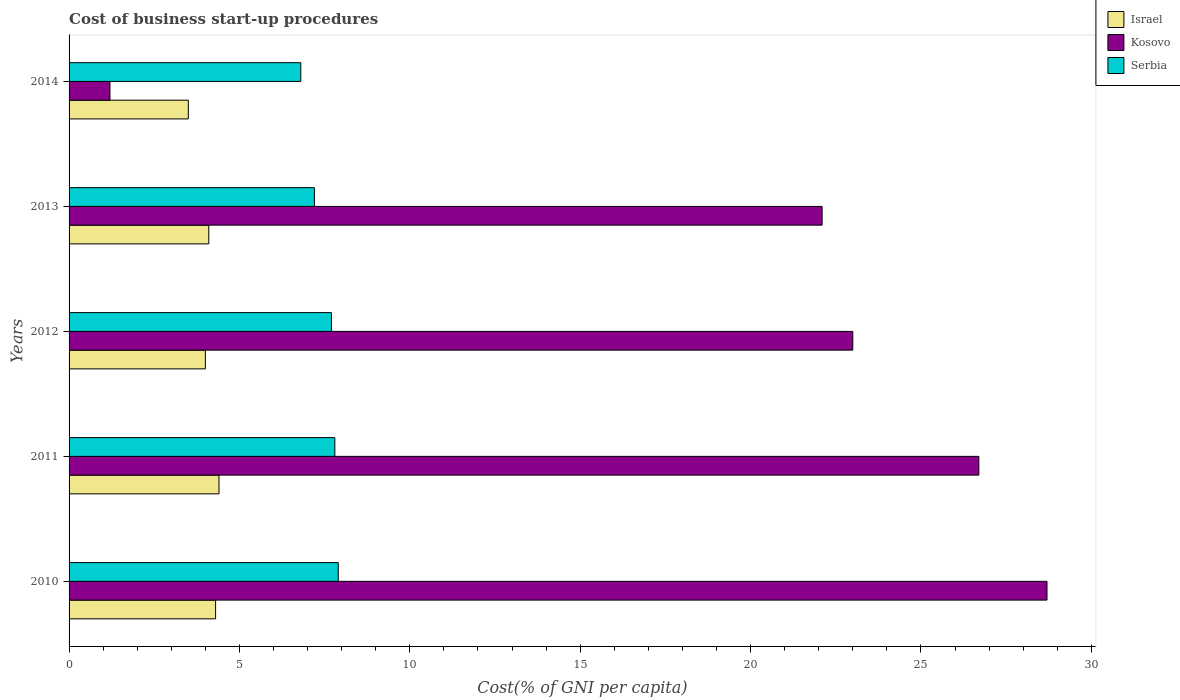How many different coloured bars are there?
Provide a short and direct response. 3. Are the number of bars per tick equal to the number of legend labels?
Give a very brief answer. Yes. In how many cases, is the number of bars for a given year not equal to the number of legend labels?
Offer a very short reply. 0. Across all years, what is the minimum cost of business start-up procedures in Israel?
Your answer should be very brief. 3.5. In which year was the cost of business start-up procedures in Serbia maximum?
Offer a terse response. 2010. What is the total cost of business start-up procedures in Israel in the graph?
Your answer should be very brief. 20.3. What is the difference between the cost of business start-up procedures in Kosovo in 2012 and that in 2014?
Provide a short and direct response. 21.8. What is the difference between the cost of business start-up procedures in Kosovo in 2011 and the cost of business start-up procedures in Israel in 2012?
Your answer should be very brief. 22.7. What is the average cost of business start-up procedures in Israel per year?
Make the answer very short. 4.06. What is the ratio of the cost of business start-up procedures in Kosovo in 2012 to that in 2014?
Give a very brief answer. 19.17. What is the difference between the highest and the second highest cost of business start-up procedures in Israel?
Make the answer very short. 0.1. What is the difference between the highest and the lowest cost of business start-up procedures in Israel?
Your answer should be very brief. 0.9. What does the 2nd bar from the top in 2014 represents?
Ensure brevity in your answer.  Kosovo. How many years are there in the graph?
Ensure brevity in your answer.  5. What is the difference between two consecutive major ticks on the X-axis?
Keep it short and to the point. 5. Are the values on the major ticks of X-axis written in scientific E-notation?
Offer a terse response. No. Does the graph contain any zero values?
Your answer should be very brief. No. Does the graph contain grids?
Provide a succinct answer. No. How are the legend labels stacked?
Your response must be concise. Vertical. What is the title of the graph?
Provide a short and direct response. Cost of business start-up procedures. What is the label or title of the X-axis?
Your response must be concise. Cost(% of GNI per capita). What is the Cost(% of GNI per capita) of Kosovo in 2010?
Keep it short and to the point. 28.7. What is the Cost(% of GNI per capita) in Serbia in 2010?
Ensure brevity in your answer.  7.9. What is the Cost(% of GNI per capita) in Kosovo in 2011?
Your answer should be compact. 26.7. What is the Cost(% of GNI per capita) in Kosovo in 2013?
Your answer should be very brief. 22.1. What is the Cost(% of GNI per capita) of Israel in 2014?
Make the answer very short. 3.5. What is the Cost(% of GNI per capita) of Serbia in 2014?
Provide a short and direct response. 6.8. Across all years, what is the maximum Cost(% of GNI per capita) in Kosovo?
Give a very brief answer. 28.7. Across all years, what is the minimum Cost(% of GNI per capita) in Kosovo?
Offer a very short reply. 1.2. What is the total Cost(% of GNI per capita) in Israel in the graph?
Make the answer very short. 20.3. What is the total Cost(% of GNI per capita) of Kosovo in the graph?
Offer a very short reply. 101.7. What is the total Cost(% of GNI per capita) in Serbia in the graph?
Your answer should be very brief. 37.4. What is the difference between the Cost(% of GNI per capita) in Israel in 2010 and that in 2011?
Your answer should be compact. -0.1. What is the difference between the Cost(% of GNI per capita) of Serbia in 2010 and that in 2011?
Provide a short and direct response. 0.1. What is the difference between the Cost(% of GNI per capita) of Israel in 2010 and that in 2013?
Give a very brief answer. 0.2. What is the difference between the Cost(% of GNI per capita) in Kosovo in 2010 and that in 2013?
Ensure brevity in your answer.  6.6. What is the difference between the Cost(% of GNI per capita) in Serbia in 2010 and that in 2013?
Provide a succinct answer. 0.7. What is the difference between the Cost(% of GNI per capita) in Kosovo in 2011 and that in 2012?
Keep it short and to the point. 3.7. What is the difference between the Cost(% of GNI per capita) of Serbia in 2011 and that in 2012?
Provide a short and direct response. 0.1. What is the difference between the Cost(% of GNI per capita) in Kosovo in 2011 and that in 2013?
Your answer should be compact. 4.6. What is the difference between the Cost(% of GNI per capita) of Israel in 2011 and that in 2014?
Your answer should be compact. 0.9. What is the difference between the Cost(% of GNI per capita) of Serbia in 2011 and that in 2014?
Make the answer very short. 1. What is the difference between the Cost(% of GNI per capita) in Israel in 2012 and that in 2014?
Your answer should be very brief. 0.5. What is the difference between the Cost(% of GNI per capita) of Kosovo in 2012 and that in 2014?
Make the answer very short. 21.8. What is the difference between the Cost(% of GNI per capita) in Serbia in 2012 and that in 2014?
Make the answer very short. 0.9. What is the difference between the Cost(% of GNI per capita) of Kosovo in 2013 and that in 2014?
Give a very brief answer. 20.9. What is the difference between the Cost(% of GNI per capita) of Israel in 2010 and the Cost(% of GNI per capita) of Kosovo in 2011?
Ensure brevity in your answer.  -22.4. What is the difference between the Cost(% of GNI per capita) of Israel in 2010 and the Cost(% of GNI per capita) of Serbia in 2011?
Your answer should be compact. -3.5. What is the difference between the Cost(% of GNI per capita) of Kosovo in 2010 and the Cost(% of GNI per capita) of Serbia in 2011?
Offer a terse response. 20.9. What is the difference between the Cost(% of GNI per capita) of Israel in 2010 and the Cost(% of GNI per capita) of Kosovo in 2012?
Your answer should be compact. -18.7. What is the difference between the Cost(% of GNI per capita) in Israel in 2010 and the Cost(% of GNI per capita) in Serbia in 2012?
Offer a terse response. -3.4. What is the difference between the Cost(% of GNI per capita) of Israel in 2010 and the Cost(% of GNI per capita) of Kosovo in 2013?
Your response must be concise. -17.8. What is the difference between the Cost(% of GNI per capita) in Kosovo in 2010 and the Cost(% of GNI per capita) in Serbia in 2014?
Offer a very short reply. 21.9. What is the difference between the Cost(% of GNI per capita) of Israel in 2011 and the Cost(% of GNI per capita) of Kosovo in 2012?
Provide a short and direct response. -18.6. What is the difference between the Cost(% of GNI per capita) of Israel in 2011 and the Cost(% of GNI per capita) of Kosovo in 2013?
Provide a short and direct response. -17.7. What is the difference between the Cost(% of GNI per capita) in Israel in 2011 and the Cost(% of GNI per capita) in Serbia in 2013?
Give a very brief answer. -2.8. What is the difference between the Cost(% of GNI per capita) of Israel in 2011 and the Cost(% of GNI per capita) of Kosovo in 2014?
Make the answer very short. 3.2. What is the difference between the Cost(% of GNI per capita) of Israel in 2012 and the Cost(% of GNI per capita) of Kosovo in 2013?
Your answer should be compact. -18.1. What is the difference between the Cost(% of GNI per capita) in Israel in 2012 and the Cost(% of GNI per capita) in Serbia in 2014?
Provide a succinct answer. -2.8. What is the difference between the Cost(% of GNI per capita) of Israel in 2013 and the Cost(% of GNI per capita) of Serbia in 2014?
Your answer should be very brief. -2.7. What is the difference between the Cost(% of GNI per capita) in Kosovo in 2013 and the Cost(% of GNI per capita) in Serbia in 2014?
Offer a terse response. 15.3. What is the average Cost(% of GNI per capita) in Israel per year?
Your answer should be compact. 4.06. What is the average Cost(% of GNI per capita) of Kosovo per year?
Offer a terse response. 20.34. What is the average Cost(% of GNI per capita) in Serbia per year?
Provide a succinct answer. 7.48. In the year 2010, what is the difference between the Cost(% of GNI per capita) of Israel and Cost(% of GNI per capita) of Kosovo?
Keep it short and to the point. -24.4. In the year 2010, what is the difference between the Cost(% of GNI per capita) of Israel and Cost(% of GNI per capita) of Serbia?
Ensure brevity in your answer.  -3.6. In the year 2010, what is the difference between the Cost(% of GNI per capita) in Kosovo and Cost(% of GNI per capita) in Serbia?
Provide a short and direct response. 20.8. In the year 2011, what is the difference between the Cost(% of GNI per capita) in Israel and Cost(% of GNI per capita) in Kosovo?
Offer a very short reply. -22.3. In the year 2011, what is the difference between the Cost(% of GNI per capita) of Israel and Cost(% of GNI per capita) of Serbia?
Provide a short and direct response. -3.4. In the year 2012, what is the difference between the Cost(% of GNI per capita) in Israel and Cost(% of GNI per capita) in Kosovo?
Your response must be concise. -19. In the year 2012, what is the difference between the Cost(% of GNI per capita) in Kosovo and Cost(% of GNI per capita) in Serbia?
Make the answer very short. 15.3. In the year 2013, what is the difference between the Cost(% of GNI per capita) in Israel and Cost(% of GNI per capita) in Kosovo?
Your response must be concise. -18. In the year 2013, what is the difference between the Cost(% of GNI per capita) of Israel and Cost(% of GNI per capita) of Serbia?
Offer a terse response. -3.1. In the year 2013, what is the difference between the Cost(% of GNI per capita) of Kosovo and Cost(% of GNI per capita) of Serbia?
Make the answer very short. 14.9. In the year 2014, what is the difference between the Cost(% of GNI per capita) in Israel and Cost(% of GNI per capita) in Kosovo?
Offer a terse response. 2.3. What is the ratio of the Cost(% of GNI per capita) in Israel in 2010 to that in 2011?
Ensure brevity in your answer.  0.98. What is the ratio of the Cost(% of GNI per capita) in Kosovo in 2010 to that in 2011?
Keep it short and to the point. 1.07. What is the ratio of the Cost(% of GNI per capita) of Serbia in 2010 to that in 2011?
Your response must be concise. 1.01. What is the ratio of the Cost(% of GNI per capita) in Israel in 2010 to that in 2012?
Ensure brevity in your answer.  1.07. What is the ratio of the Cost(% of GNI per capita) in Kosovo in 2010 to that in 2012?
Your answer should be very brief. 1.25. What is the ratio of the Cost(% of GNI per capita) of Israel in 2010 to that in 2013?
Your answer should be compact. 1.05. What is the ratio of the Cost(% of GNI per capita) of Kosovo in 2010 to that in 2013?
Offer a terse response. 1.3. What is the ratio of the Cost(% of GNI per capita) in Serbia in 2010 to that in 2013?
Your answer should be very brief. 1.1. What is the ratio of the Cost(% of GNI per capita) of Israel in 2010 to that in 2014?
Provide a short and direct response. 1.23. What is the ratio of the Cost(% of GNI per capita) of Kosovo in 2010 to that in 2014?
Keep it short and to the point. 23.92. What is the ratio of the Cost(% of GNI per capita) of Serbia in 2010 to that in 2014?
Provide a short and direct response. 1.16. What is the ratio of the Cost(% of GNI per capita) of Kosovo in 2011 to that in 2012?
Make the answer very short. 1.16. What is the ratio of the Cost(% of GNI per capita) of Serbia in 2011 to that in 2012?
Provide a succinct answer. 1.01. What is the ratio of the Cost(% of GNI per capita) of Israel in 2011 to that in 2013?
Offer a terse response. 1.07. What is the ratio of the Cost(% of GNI per capita) of Kosovo in 2011 to that in 2013?
Ensure brevity in your answer.  1.21. What is the ratio of the Cost(% of GNI per capita) in Serbia in 2011 to that in 2013?
Ensure brevity in your answer.  1.08. What is the ratio of the Cost(% of GNI per capita) in Israel in 2011 to that in 2014?
Ensure brevity in your answer.  1.26. What is the ratio of the Cost(% of GNI per capita) in Kosovo in 2011 to that in 2014?
Offer a very short reply. 22.25. What is the ratio of the Cost(% of GNI per capita) of Serbia in 2011 to that in 2014?
Offer a terse response. 1.15. What is the ratio of the Cost(% of GNI per capita) in Israel in 2012 to that in 2013?
Provide a succinct answer. 0.98. What is the ratio of the Cost(% of GNI per capita) of Kosovo in 2012 to that in 2013?
Provide a short and direct response. 1.04. What is the ratio of the Cost(% of GNI per capita) of Serbia in 2012 to that in 2013?
Your response must be concise. 1.07. What is the ratio of the Cost(% of GNI per capita) of Kosovo in 2012 to that in 2014?
Ensure brevity in your answer.  19.17. What is the ratio of the Cost(% of GNI per capita) in Serbia in 2012 to that in 2014?
Keep it short and to the point. 1.13. What is the ratio of the Cost(% of GNI per capita) in Israel in 2013 to that in 2014?
Make the answer very short. 1.17. What is the ratio of the Cost(% of GNI per capita) of Kosovo in 2013 to that in 2014?
Your answer should be compact. 18.42. What is the ratio of the Cost(% of GNI per capita) of Serbia in 2013 to that in 2014?
Make the answer very short. 1.06. What is the difference between the highest and the second highest Cost(% of GNI per capita) in Israel?
Your answer should be very brief. 0.1. What is the difference between the highest and the second highest Cost(% of GNI per capita) in Kosovo?
Your answer should be compact. 2. What is the difference between the highest and the lowest Cost(% of GNI per capita) of Israel?
Provide a succinct answer. 0.9. 